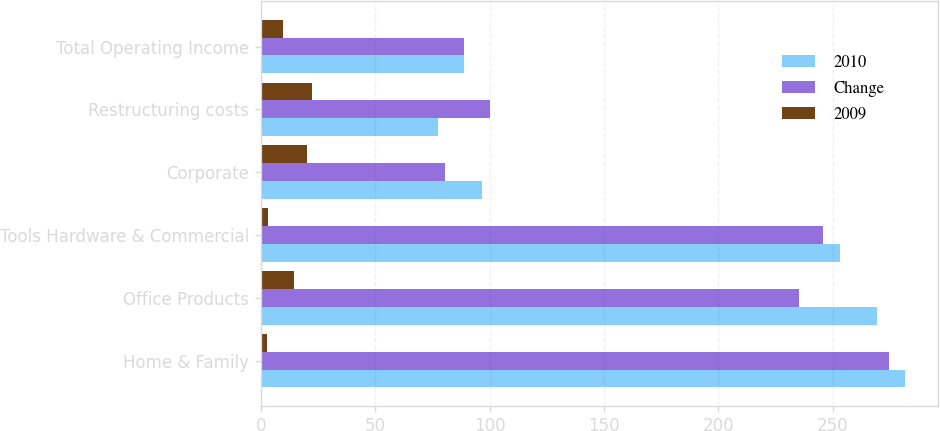Convert chart to OTSL. <chart><loc_0><loc_0><loc_500><loc_500><stacked_bar_chart><ecel><fcel>Home & Family<fcel>Office Products<fcel>Tools Hardware & Commercial<fcel>Corporate<fcel>Restructuring costs<fcel>Total Operating Income<nl><fcel>2010<fcel>281.8<fcel>269.4<fcel>253.1<fcel>96.9<fcel>77.5<fcel>88.75<nl><fcel>Change<fcel>274.7<fcel>235.2<fcel>245.6<fcel>80.6<fcel>100<fcel>88.75<nl><fcel>2009<fcel>2.6<fcel>14.5<fcel>3.1<fcel>20.2<fcel>22.5<fcel>9.6<nl></chart> 